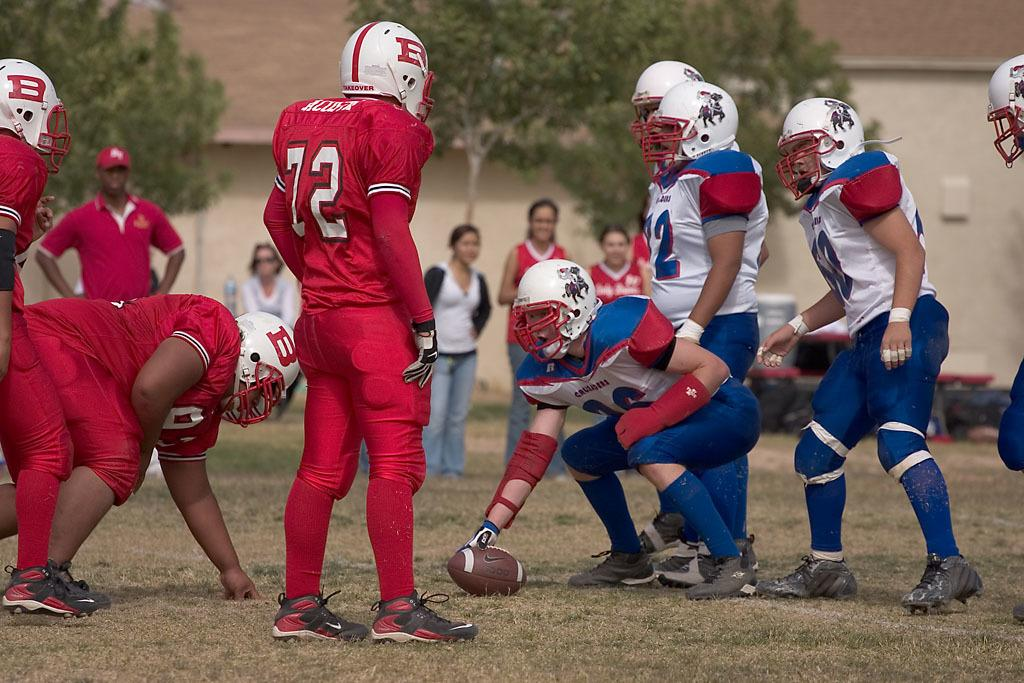Who or what is present in the image? There are people in the image. What type of terrain can be seen in the image? There is grass and sand in the image. What can be seen in the background of the image? There are trees in the background of the image. What type of structure is visible in the image? There is a house in the image. How many ants can be seen crawling on the end of the nail in the image? There are no ants or nails present in the image. 